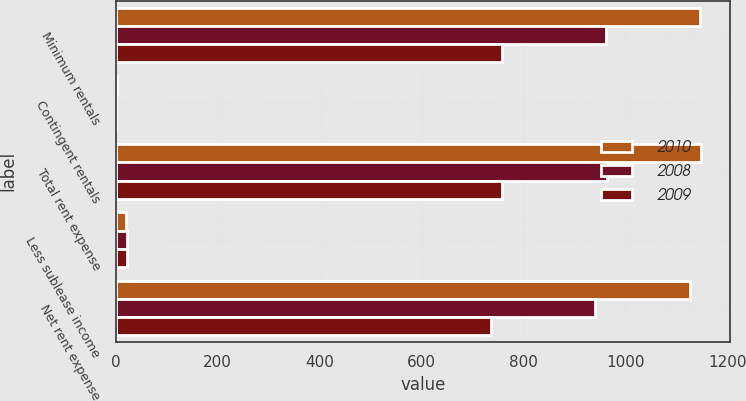Convert chart to OTSL. <chart><loc_0><loc_0><loc_500><loc_500><stacked_bar_chart><ecel><fcel>Minimum rentals<fcel>Contingent rentals<fcel>Total rent expense<fcel>Less sublease income<fcel>Net rent expense<nl><fcel>2010<fcel>1145<fcel>2<fcel>1147<fcel>20<fcel>1127<nl><fcel>2008<fcel>962<fcel>1<fcel>963<fcel>23<fcel>940<nl><fcel>2009<fcel>757<fcel>1<fcel>758<fcel>22<fcel>736<nl></chart> 